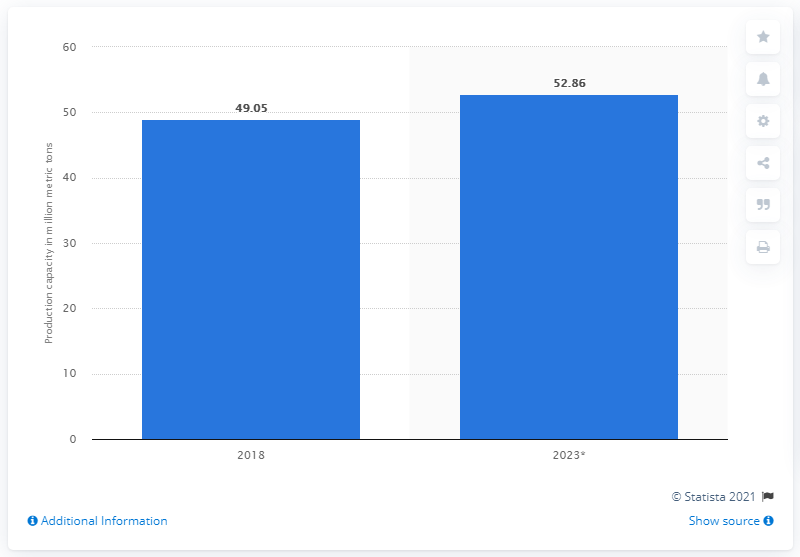Indicate a few pertinent items in this graphic. The global production capacity of vinyl chloride monomer is 52.86 million metric tons per year. In 2018, the production capacity of vinyl chloride monomer was 49.05. 